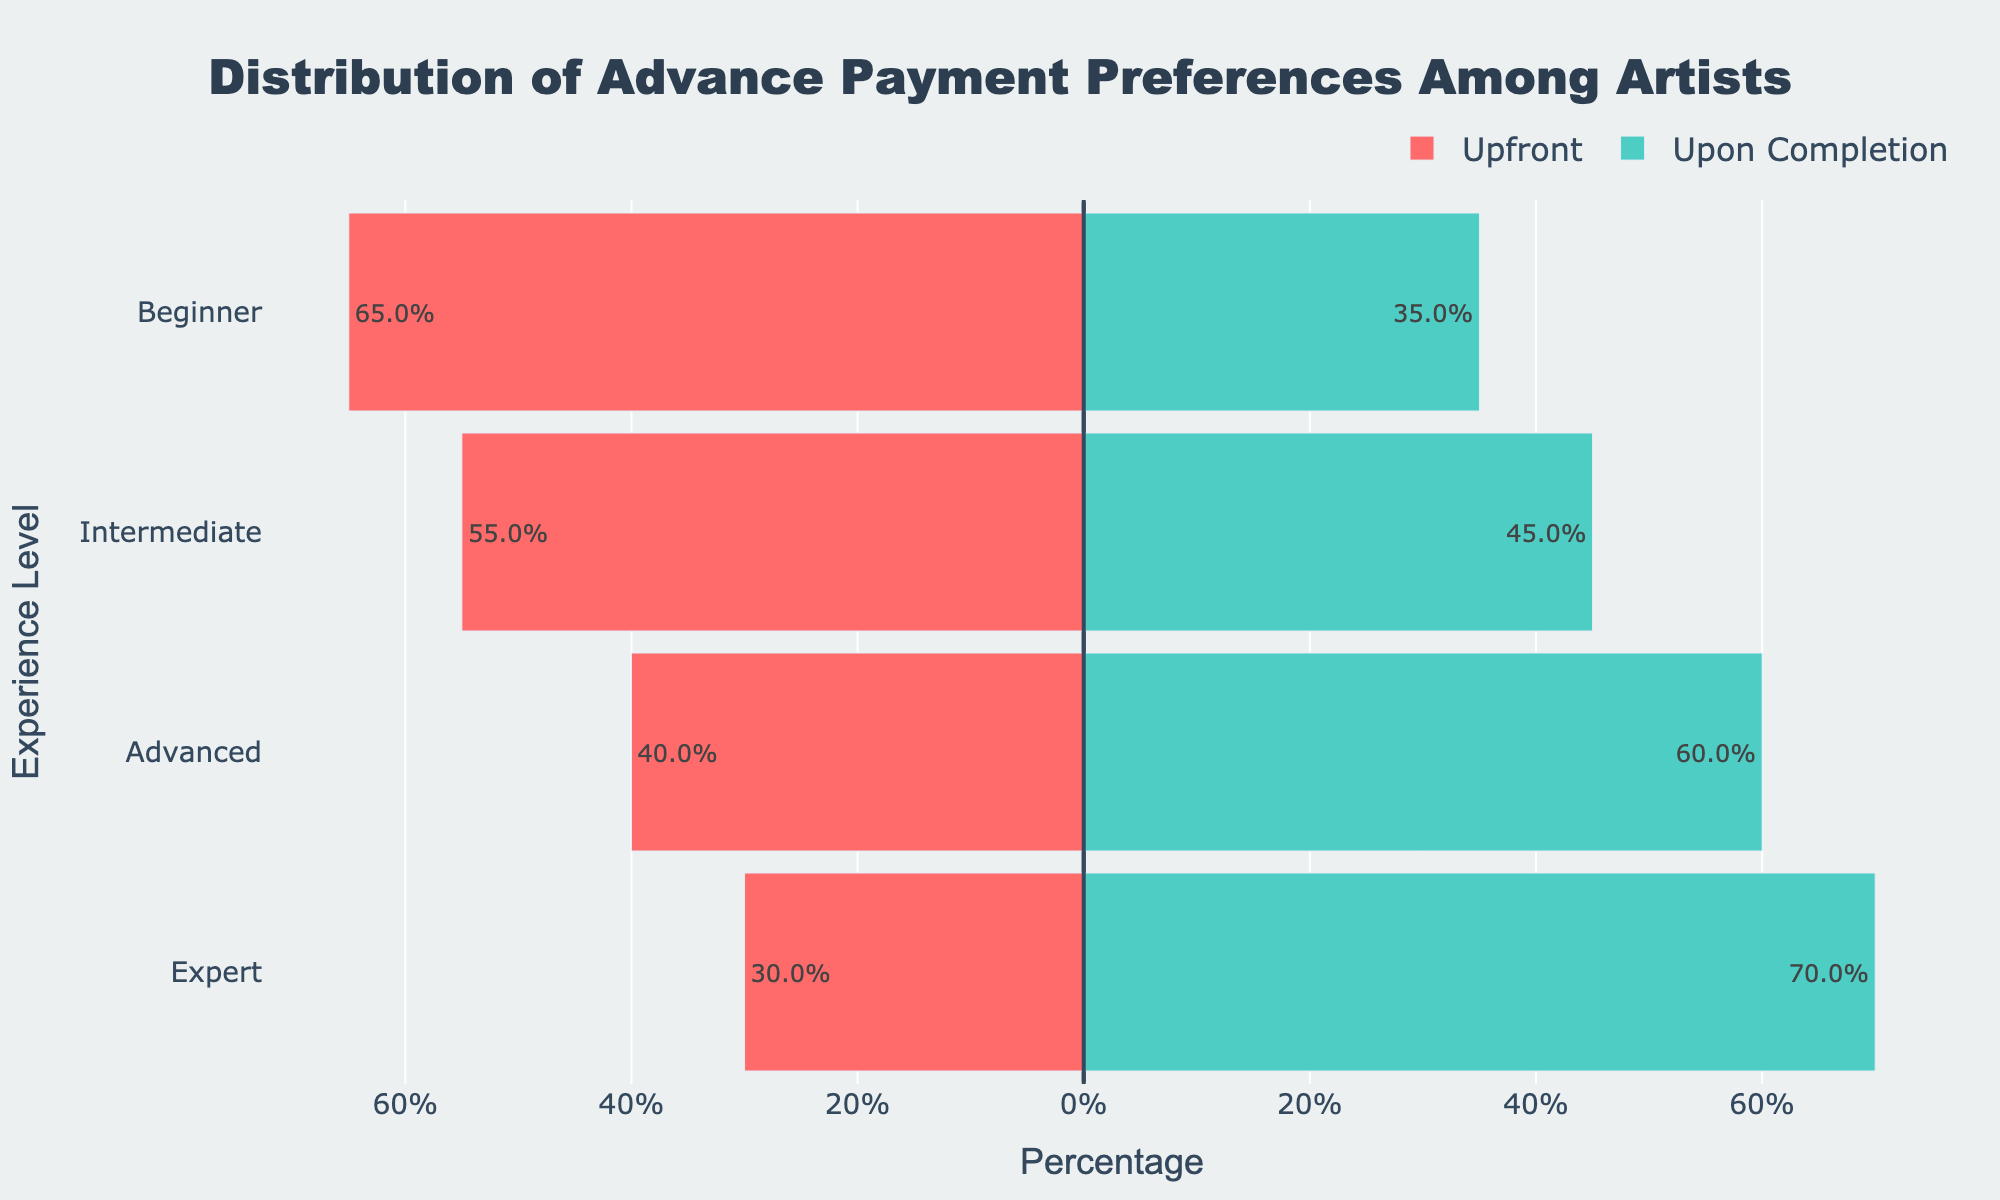Which experience level has the highest percentage of artists preferring payment upon completion? The artists at the Expert level have the highest preference for payment upon completion. This can be seen by looking at the rightmost bars (green) where the Expert bar is the longest.
Answer: Expert How much higher is the percentage of Expert artists preferring upon completion compared to Advanced artists? Expert artists have a 70% preference for payment upon completion, while Advanced artists have a 60% preference. Subtract 60% from 70% to find the difference.
Answer: 10% What is the combined percentage of Beginner and Intermediate artists preferring upfront payment? The Beginner percentage for upfront payment is 65%, and the Intermediate percentage is 55%. Adding these percentages gives the combined percentage: 65% + 55% = 120%.
Answer: 120% Which experience level shows the smallest preference for upfront payment? The smallest preference for upfront payment can be seen in the bar that is shortest among the red bars, which is at the Expert level at 30%.
Answer: Expert On average, how do the upfront payment preferences compare between Beginner and Advanced artists? Beginners have a 65% preference, and Advanced artists have a 40% preference for upfront payment. Calculate the average by (65% + 40%) / 2 = 52.5%.
Answer: 52.5% Which experience level has almost equal preferences for upfront and upon completion payments? The closest to equal preferences are the Intermediate artists, where the percentages are 55% (upfront) and 45% (upon completion), which are close to each other.
Answer: Intermediate Is the trend of preference for upfront payment increasing or decreasing with experience level? As you move from Beginner to Expert levels, the length of the red bars (upfront payment) decreases consistently. This shows a decreasing trend.
Answer: Decreasing How much higher is the percentage of Beginner artists preferring upfront payment compared to Expert artists? Beginner artists have a 65% preference for upfront payment, while Expert artists have a 30% preference. Subtract 30% from 65% to find the difference.
Answer: 35% Which experience level shows the most balanced distribution between the two payment preferences? The most balanced distribution is at the Intermediate level, where the percentages are 55% upfront and 45% upon completion.
Answer: Intermediate What is the percentage difference between the highest and lowest payment upon completion preferences? The highest payment upon completion preference is 70% (Expert), and the lowest is 35% (Beginner). Subtract 35% from 70% to find the difference.
Answer: 35% 